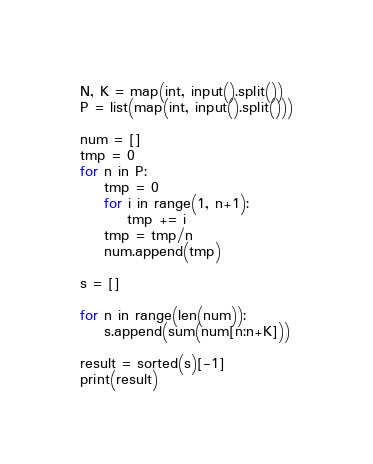Convert code to text. <code><loc_0><loc_0><loc_500><loc_500><_Python_>N, K = map(int, input().split())
P = list(map(int, input().split()))

num = []
tmp = 0
for n in P:
    tmp = 0
    for i in range(1, n+1):
        tmp += i
    tmp = tmp/n
    num.append(tmp)

s = []

for n in range(len(num)):
    s.append(sum(num[n:n+K]))

result = sorted(s)[-1]
print(result)
</code> 